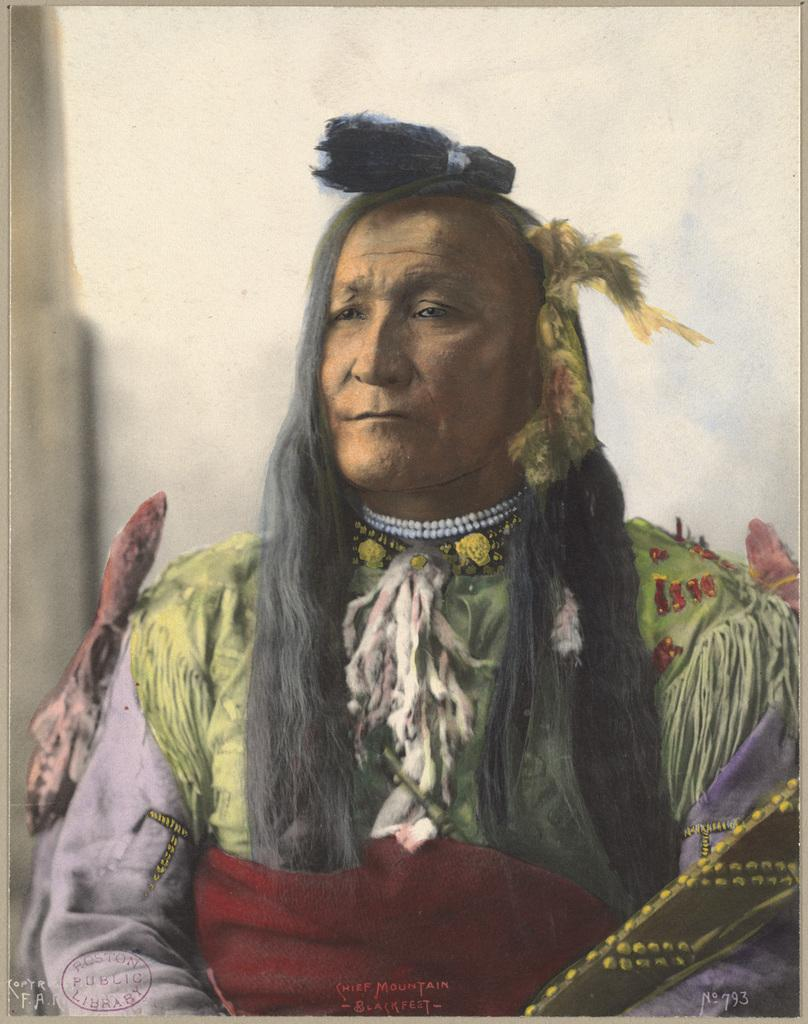What is the main subject of the painting in the image? The painting depicts a woman. What is the woman wearing in the painting? The woman is wearing a dress and a locket in the painting. What can be seen in the background of the painting? There is a wall visible in the background of the painting. Can you tell me how many zebras are in the painting? There are no zebras present in the painting; it features a woman wearing a dress and a locket. What type of pickle is the woman holding in the painting? There is no pickle present in the painting; the woman is wearing a locket and a dress. 